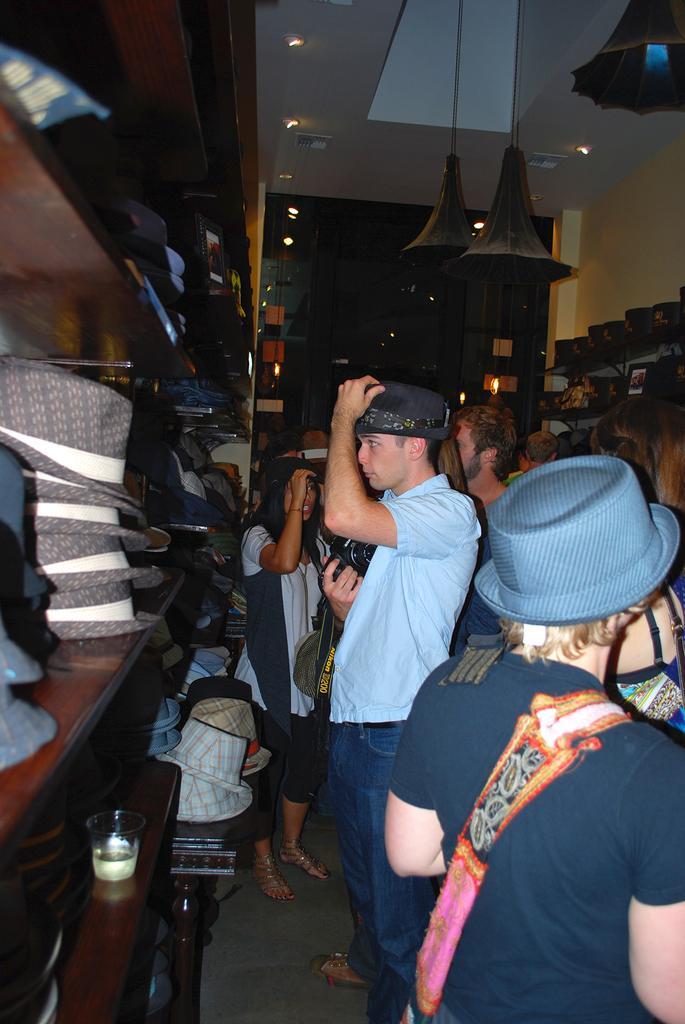In one or two sentences, can you explain what this image depicts? This picture is clicked inside. On the right we can see the group of persons standing on the ground. On the left we can see the wooden cabinet containing many number of hats and we can see the glass of water. At the top there is a roof and we can see the ceiling lights and there are some objects hanging on the roof. In the background we can see the wooden door and many other objects. 